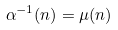<formula> <loc_0><loc_0><loc_500><loc_500>\alpha ^ { - 1 } ( n ) = \mu ( n )</formula> 